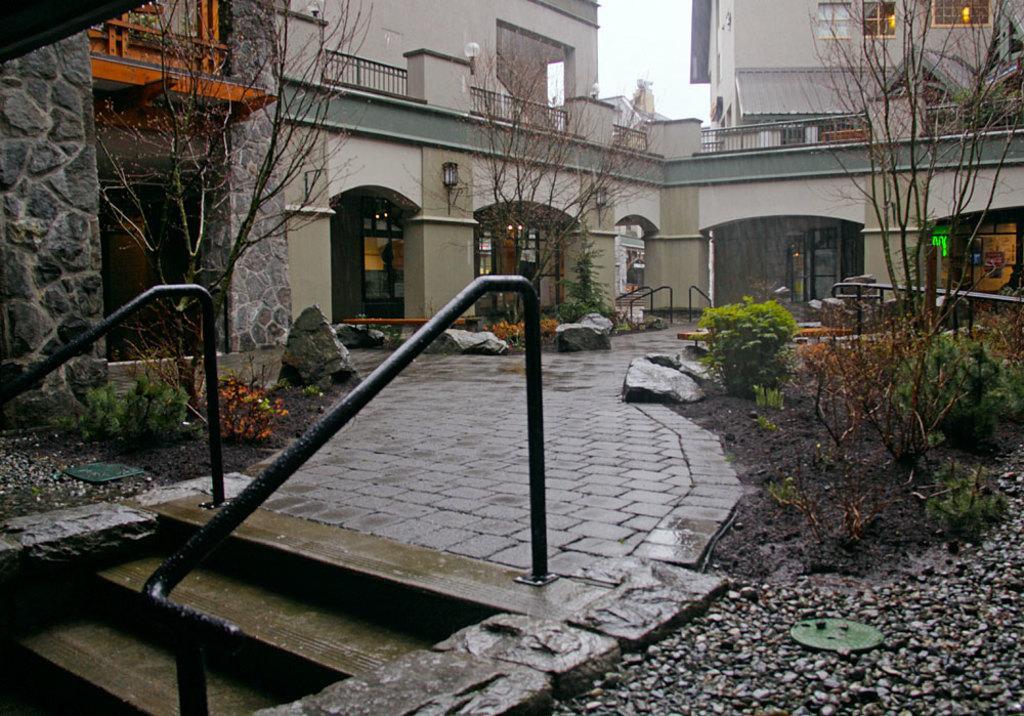Could you give a brief overview of what you see in this image? This image is taken outdoors. At the bottom of the image there is a ground with pebbles and a few plants and there is a floor. There are a few stairs and a railing. In the middle of the image there are two buildings with walls, windows, doors, railings and balconies. There are a few trees and plants. 